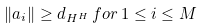<formula> <loc_0><loc_0><loc_500><loc_500>\| a _ { i } \| \geq d _ { H ^ { H } } \, f o r \, 1 \leq i \leq M</formula> 